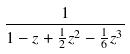<formula> <loc_0><loc_0><loc_500><loc_500>\frac { 1 } { 1 - z + \frac { 1 } { 2 } z ^ { 2 } - \frac { 1 } { 6 } z ^ { 3 } }</formula> 